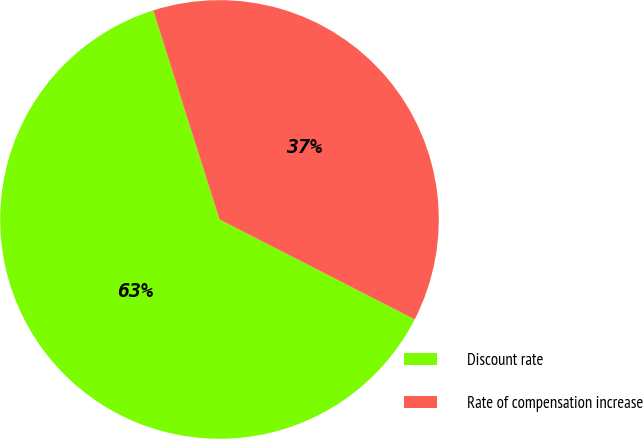Convert chart to OTSL. <chart><loc_0><loc_0><loc_500><loc_500><pie_chart><fcel>Discount rate<fcel>Rate of compensation increase<nl><fcel>62.58%<fcel>37.42%<nl></chart> 